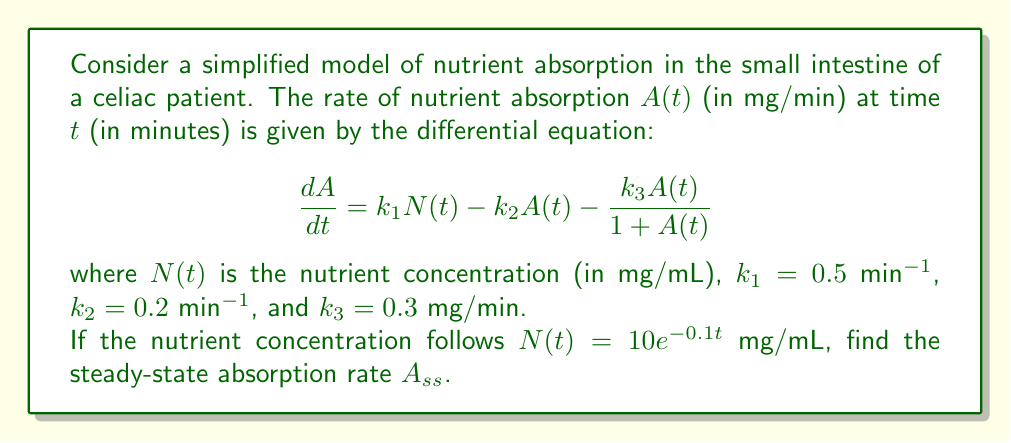Solve this math problem. To find the steady-state absorption rate, we need to follow these steps:

1) At steady-state, the rate of change of absorption is zero:

   $$\frac{dA}{dt} = 0$$

2) Substitute this into the given differential equation:

   $$0 = k_1N(t) - k_2A_{ss} - \frac{k_3A_{ss}}{1 + A_{ss}}$$

3) At $t \to \infty$, $N(t) \to 0$ (since $N(t) = 10e^{-0.1t}$). So, we have:

   $$0 = 0 - k_2A_{ss} - \frac{k_3A_{ss}}{1 + A_{ss}}$$

4) Substitute the given values for $k_2$ and $k_3$:

   $$0 = -0.2A_{ss} - \frac{0.3A_{ss}}{1 + A_{ss}}$$

5) Multiply both sides by $(1 + A_{ss})$:

   $$0 = -0.2A_{ss}(1 + A_{ss}) - 0.3A_{ss}$$

6) Expand:

   $$0 = -0.2A_{ss} - 0.2A_{ss}^2 - 0.3A_{ss}$$

7) Combine like terms:

   $$0 = -0.5A_{ss} - 0.2A_{ss}^2$$

8) Factor out $A_{ss}$:

   $$0 = A_{ss}(-0.5 - 0.2A_{ss})$$

9) Solve for $A_{ss}$:
   Either $A_{ss} = 0$ or $-0.5 - 0.2A_{ss} = 0$

   From the second equation:
   $$A_{ss} = -\frac{0.5}{0.2} = -2.5$$

10) Since absorption rate cannot be negative, the only physiologically meaningful solution is:

    $$A_{ss} = 0$$
Answer: $A_{ss} = 0$ mg/min 